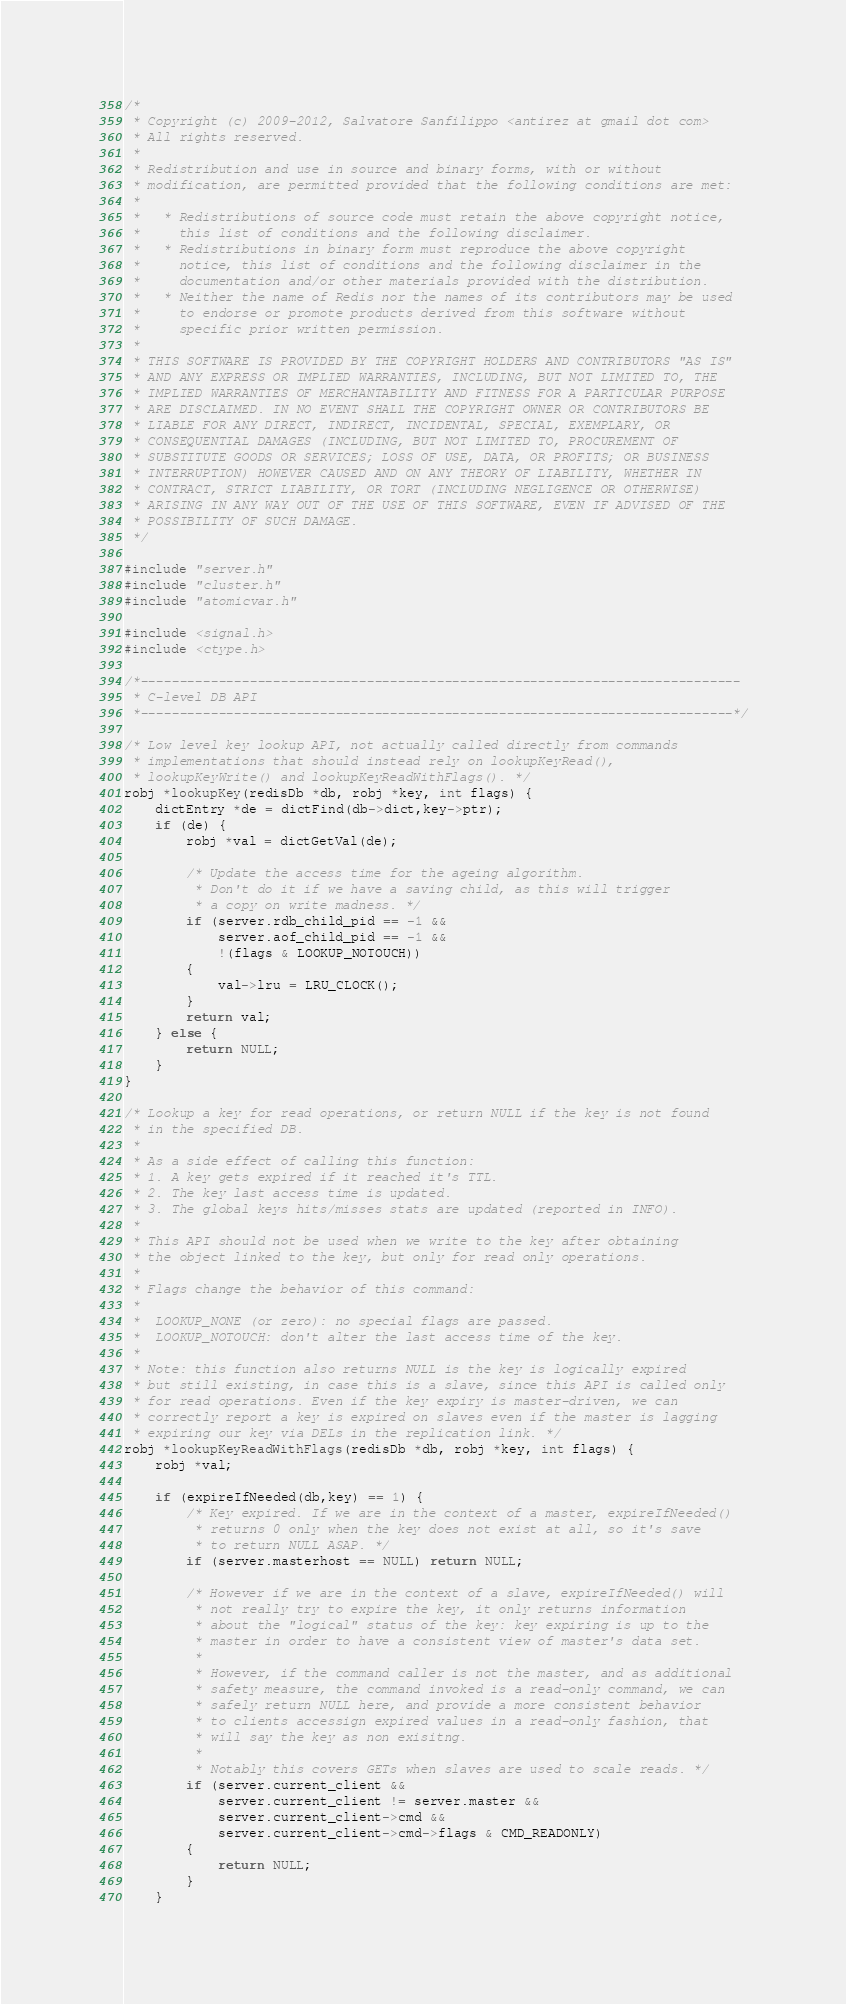Convert code to text. <code><loc_0><loc_0><loc_500><loc_500><_C_>/*
 * Copyright (c) 2009-2012, Salvatore Sanfilippo <antirez at gmail dot com>
 * All rights reserved.
 *
 * Redistribution and use in source and binary forms, with or without
 * modification, are permitted provided that the following conditions are met:
 *
 *   * Redistributions of source code must retain the above copyright notice,
 *     this list of conditions and the following disclaimer.
 *   * Redistributions in binary form must reproduce the above copyright
 *     notice, this list of conditions and the following disclaimer in the
 *     documentation and/or other materials provided with the distribution.
 *   * Neither the name of Redis nor the names of its contributors may be used
 *     to endorse or promote products derived from this software without
 *     specific prior written permission.
 *
 * THIS SOFTWARE IS PROVIDED BY THE COPYRIGHT HOLDERS AND CONTRIBUTORS "AS IS"
 * AND ANY EXPRESS OR IMPLIED WARRANTIES, INCLUDING, BUT NOT LIMITED TO, THE
 * IMPLIED WARRANTIES OF MERCHANTABILITY AND FITNESS FOR A PARTICULAR PURPOSE
 * ARE DISCLAIMED. IN NO EVENT SHALL THE COPYRIGHT OWNER OR CONTRIBUTORS BE
 * LIABLE FOR ANY DIRECT, INDIRECT, INCIDENTAL, SPECIAL, EXEMPLARY, OR
 * CONSEQUENTIAL DAMAGES (INCLUDING, BUT NOT LIMITED TO, PROCUREMENT OF
 * SUBSTITUTE GOODS OR SERVICES; LOSS OF USE, DATA, OR PROFITS; OR BUSINESS
 * INTERRUPTION) HOWEVER CAUSED AND ON ANY THEORY OF LIABILITY, WHETHER IN
 * CONTRACT, STRICT LIABILITY, OR TORT (INCLUDING NEGLIGENCE OR OTHERWISE)
 * ARISING IN ANY WAY OUT OF THE USE OF THIS SOFTWARE, EVEN IF ADVISED OF THE
 * POSSIBILITY OF SUCH DAMAGE.
 */

#include "server.h"
#include "cluster.h"
#include "atomicvar.h"

#include <signal.h>
#include <ctype.h>

/*-----------------------------------------------------------------------------
 * C-level DB API
 *----------------------------------------------------------------------------*/

/* Low level key lookup API, not actually called directly from commands
 * implementations that should instead rely on lookupKeyRead(),
 * lookupKeyWrite() and lookupKeyReadWithFlags(). */
robj *lookupKey(redisDb *db, robj *key, int flags) {
    dictEntry *de = dictFind(db->dict,key->ptr);
    if (de) {
        robj *val = dictGetVal(de);

        /* Update the access time for the ageing algorithm.
         * Don't do it if we have a saving child, as this will trigger
         * a copy on write madness. */
        if (server.rdb_child_pid == -1 &&
            server.aof_child_pid == -1 &&
            !(flags & LOOKUP_NOTOUCH))
        {
            val->lru = LRU_CLOCK();
        }
        return val;
    } else {
        return NULL;
    }
}

/* Lookup a key for read operations, or return NULL if the key is not found
 * in the specified DB.
 *
 * As a side effect of calling this function:
 * 1. A key gets expired if it reached it's TTL.
 * 2. The key last access time is updated.
 * 3. The global keys hits/misses stats are updated (reported in INFO).
 *
 * This API should not be used when we write to the key after obtaining
 * the object linked to the key, but only for read only operations.
 *
 * Flags change the behavior of this command:
 *
 *  LOOKUP_NONE (or zero): no special flags are passed.
 *  LOOKUP_NOTOUCH: don't alter the last access time of the key.
 *
 * Note: this function also returns NULL is the key is logically expired
 * but still existing, in case this is a slave, since this API is called only
 * for read operations. Even if the key expiry is master-driven, we can
 * correctly report a key is expired on slaves even if the master is lagging
 * expiring our key via DELs in the replication link. */
robj *lookupKeyReadWithFlags(redisDb *db, robj *key, int flags) {
    robj *val;

    if (expireIfNeeded(db,key) == 1) {
        /* Key expired. If we are in the context of a master, expireIfNeeded()
         * returns 0 only when the key does not exist at all, so it's save
         * to return NULL ASAP. */
        if (server.masterhost == NULL) return NULL;

        /* However if we are in the context of a slave, expireIfNeeded() will
         * not really try to expire the key, it only returns information
         * about the "logical" status of the key: key expiring is up to the
         * master in order to have a consistent view of master's data set.
         *
         * However, if the command caller is not the master, and as additional
         * safety measure, the command invoked is a read-only command, we can
         * safely return NULL here, and provide a more consistent behavior
         * to clients accessign expired values in a read-only fashion, that
         * will say the key as non exisitng.
         *
         * Notably this covers GETs when slaves are used to scale reads. */
        if (server.current_client &&
            server.current_client != server.master &&
            server.current_client->cmd &&
            server.current_client->cmd->flags & CMD_READONLY)
        {
            return NULL;
        }
    }</code> 